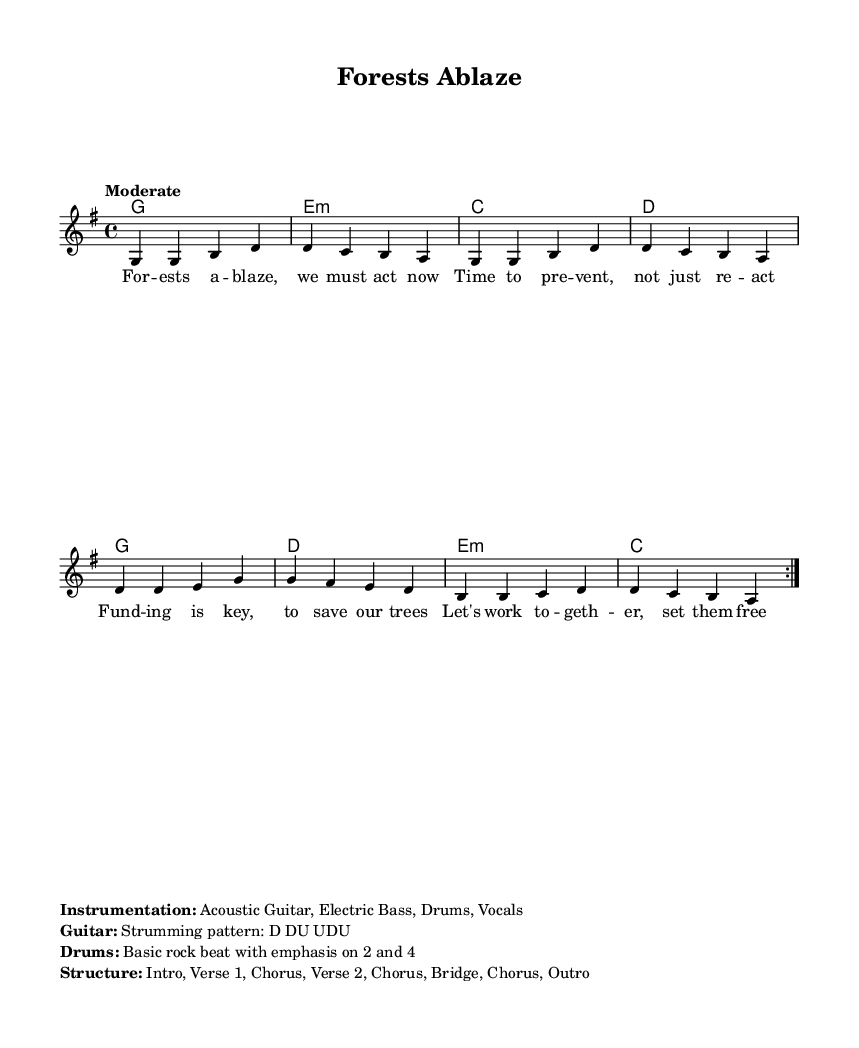What is the key signature of this music? The key signature is G major, which has one sharp (F#). This is determined by examining the global settings at the beginning of the sheet music where it states \key g \major.
Answer: G major What is the time signature of this piece? The time signature is 4/4, which is indicated in the global settings. This means there are four beats in each measure, and the quarter note gets one beat.
Answer: 4/4 What is the tempo for this music? The tempo is marked "Moderate" in the global settings, indicating a medium speed in the performance.
Answer: Moderate How many measures are in the verse section? The verse section consists of 8 measures, as noted in the repeated volta section where the melody and lyrics indicate a repeat of the verse. Each repeat represents a full cycle of the verse.
Answer: 8 measures What is the primary instrument used? The primary instrument used is the Acoustic Guitar, as indicated in the instrumentation details at the bottom of the sheet music.
Answer: Acoustic Guitar What is the unique strumming pattern indicated for the guitar? The unique strumming pattern indicated is D DU UDU, which specifies the down-up pattern for playing chords on the guitar. This pattern is noted under the guitar section of the instrumentation markup.
Answer: D DU UDU How many times is the chorus repeated? The chorus is repeated 3 times, as inferred from the structure layout of the song which outlines where the chorus is placed in relation to verses and the bridge.
Answer: 3 times 